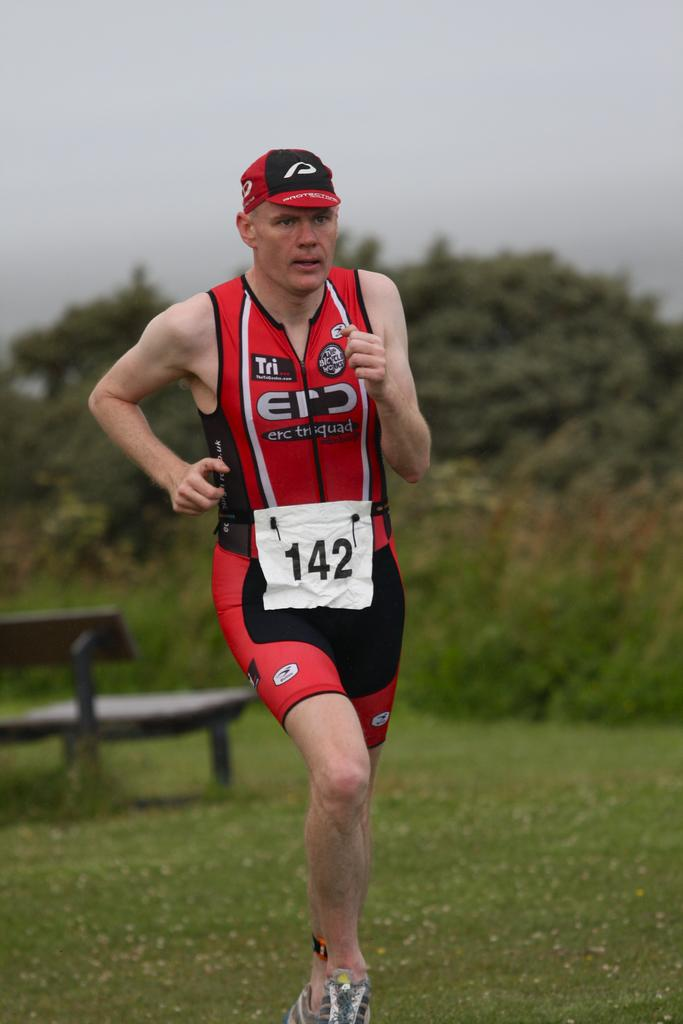Provide a one-sentence caption for the provided image. A runner wearing number 142 runs across a grassy area. 